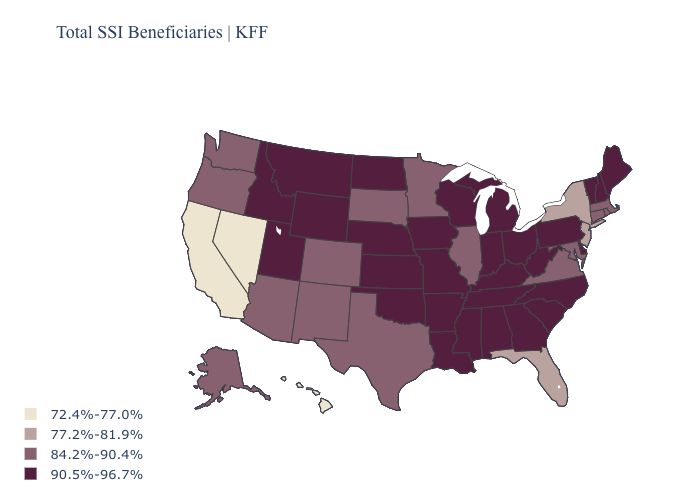What is the value of Kentucky?
Give a very brief answer. 90.5%-96.7%. What is the value of North Dakota?
Be succinct. 90.5%-96.7%. Does California have a higher value than Vermont?
Concise answer only. No. What is the lowest value in the USA?
Be succinct. 72.4%-77.0%. Which states hav the highest value in the South?
Answer briefly. Alabama, Arkansas, Delaware, Georgia, Kentucky, Louisiana, Mississippi, North Carolina, Oklahoma, South Carolina, Tennessee, West Virginia. What is the highest value in the Northeast ?
Keep it brief. 90.5%-96.7%. What is the value of Florida?
Be succinct. 77.2%-81.9%. What is the highest value in states that border West Virginia?
Give a very brief answer. 90.5%-96.7%. What is the value of Wisconsin?
Quick response, please. 90.5%-96.7%. Name the states that have a value in the range 84.2%-90.4%?
Quick response, please. Alaska, Arizona, Colorado, Connecticut, Illinois, Maryland, Massachusetts, Minnesota, New Mexico, Oregon, Rhode Island, South Dakota, Texas, Virginia, Washington. What is the value of North Carolina?
Keep it brief. 90.5%-96.7%. What is the highest value in states that border Arizona?
Keep it brief. 90.5%-96.7%. Does Illinois have the lowest value in the USA?
Quick response, please. No. What is the highest value in the West ?
Concise answer only. 90.5%-96.7%. 